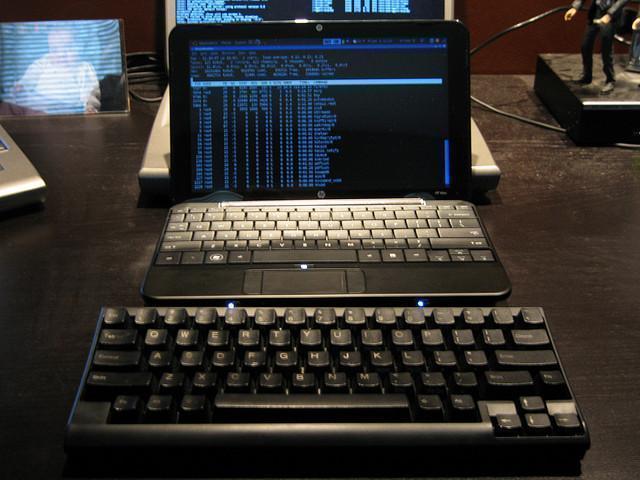Based on what's shown on the computer screen what is this person doing?
Answer the question by selecting the correct answer among the 4 following choices.
Options: Writing fiction, shopping list, programming, gaming. Programming. 